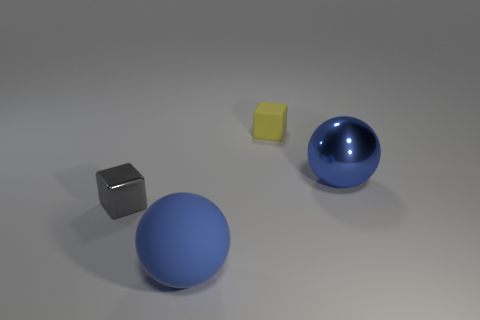Add 3 small objects. How many objects exist? 7 Subtract all big blue metallic cylinders. Subtract all cubes. How many objects are left? 2 Add 1 rubber objects. How many rubber objects are left? 3 Add 2 small blue rubber cylinders. How many small blue rubber cylinders exist? 2 Subtract 1 yellow blocks. How many objects are left? 3 